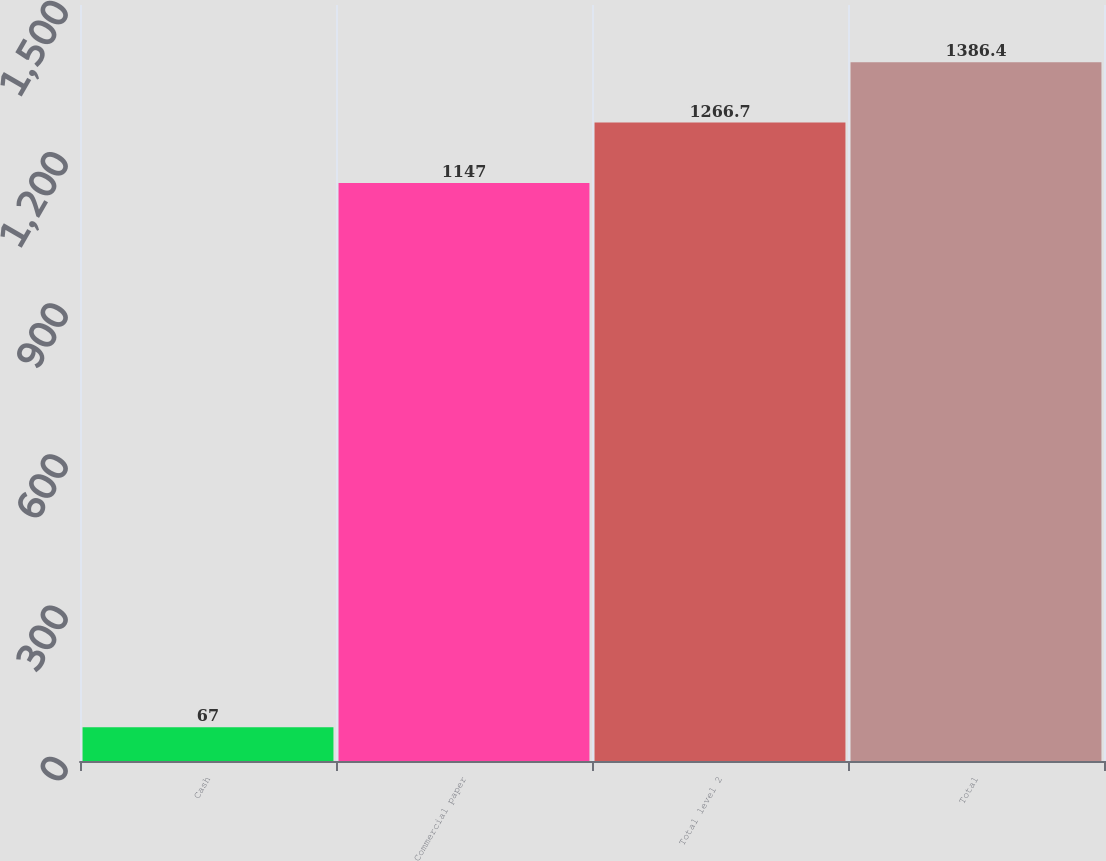Convert chart. <chart><loc_0><loc_0><loc_500><loc_500><bar_chart><fcel>Cash<fcel>Commercial paper<fcel>Total level 2<fcel>Total<nl><fcel>67<fcel>1147<fcel>1266.7<fcel>1386.4<nl></chart> 